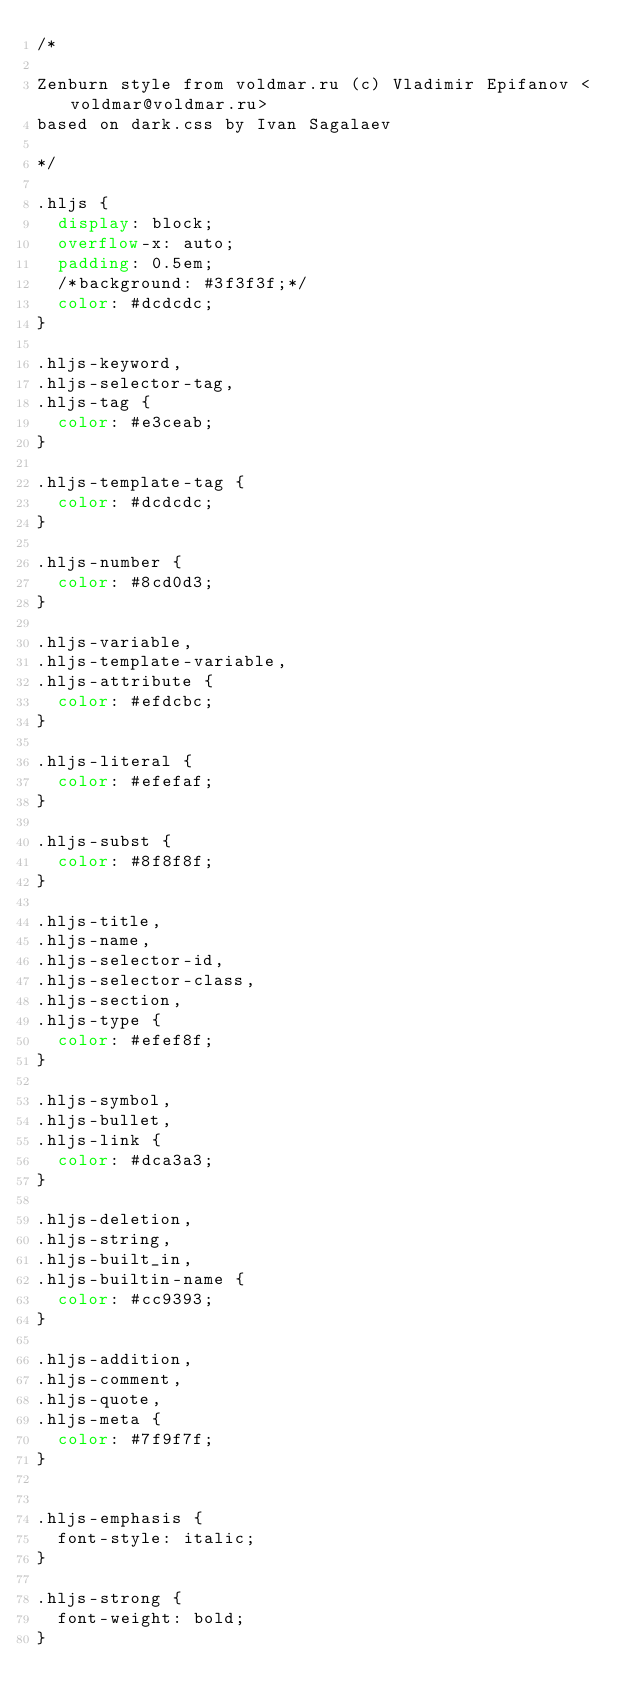Convert code to text. <code><loc_0><loc_0><loc_500><loc_500><_CSS_>/*

Zenburn style from voldmar.ru (c) Vladimir Epifanov <voldmar@voldmar.ru>
based on dark.css by Ivan Sagalaev

*/

.hljs {
  display: block;
  overflow-x: auto;
  padding: 0.5em;
  /*background: #3f3f3f;*/
  color: #dcdcdc;
}

.hljs-keyword,
.hljs-selector-tag,
.hljs-tag {
  color: #e3ceab;
}

.hljs-template-tag {
  color: #dcdcdc;
}

.hljs-number {
  color: #8cd0d3;
}

.hljs-variable,
.hljs-template-variable,
.hljs-attribute {
  color: #efdcbc;
}

.hljs-literal {
  color: #efefaf;
}

.hljs-subst {
  color: #8f8f8f;
}

.hljs-title,
.hljs-name,
.hljs-selector-id,
.hljs-selector-class,
.hljs-section,
.hljs-type {
  color: #efef8f;
}

.hljs-symbol,
.hljs-bullet,
.hljs-link {
  color: #dca3a3;
}

.hljs-deletion,
.hljs-string,
.hljs-built_in,
.hljs-builtin-name {
  color: #cc9393;
}

.hljs-addition,
.hljs-comment,
.hljs-quote,
.hljs-meta {
  color: #7f9f7f;
}


.hljs-emphasis {
  font-style: italic;
}

.hljs-strong {
  font-weight: bold;
}
</code> 